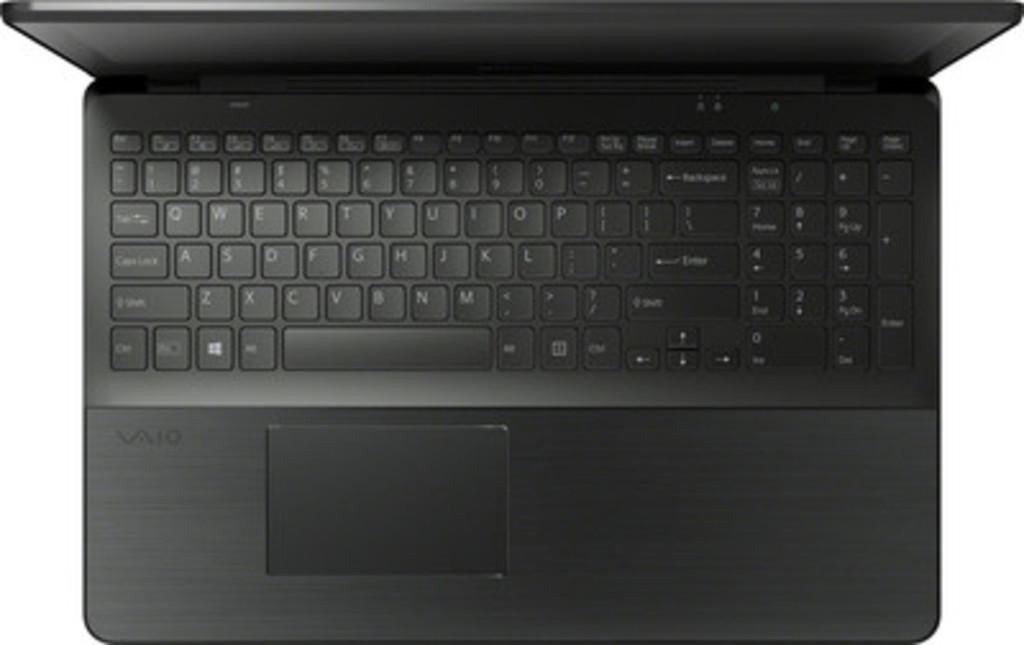What electronic device is visible in the image? There is a laptop in the image. What is the primary function of the device in the image? The laptop is designed for computing and processing tasks. Can you describe the appearance of the laptop in the image? The laptop appears to be closed, with a screen and keyboard visible. What type of blade is being used to cut the laptop in the image? There is no blade present in the image, and the laptop is not being cut. 